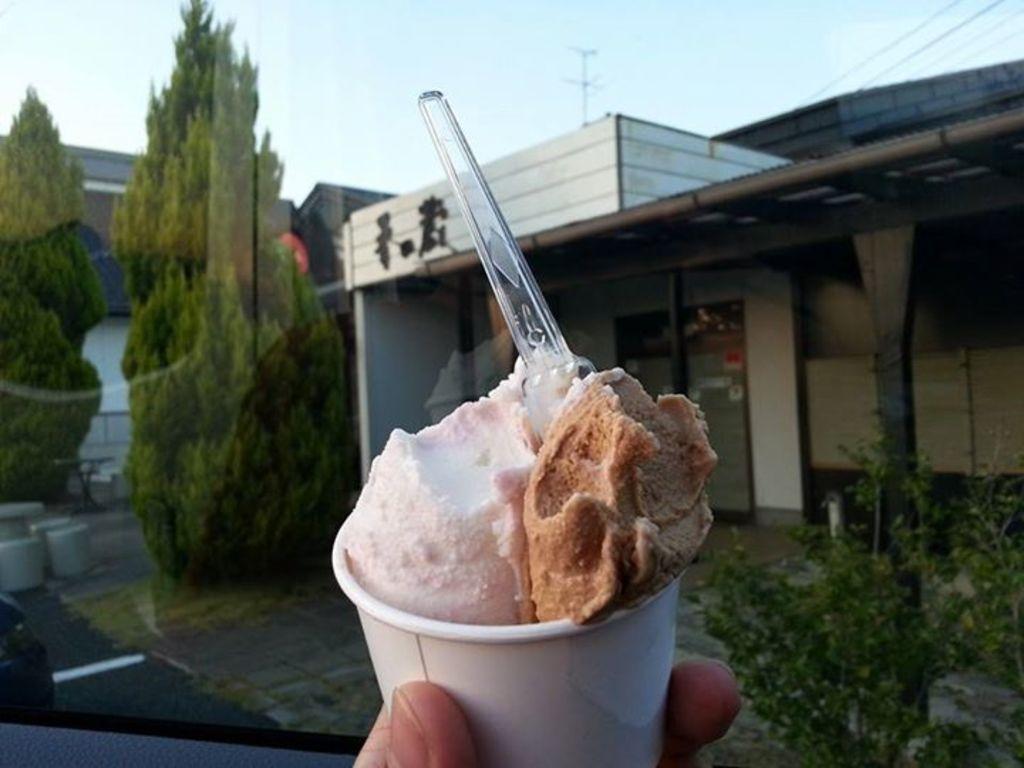Describe this image in one or two sentences. As we can see in the image there is a building, trees, plant, cup, ice cream, spoon and sky. 